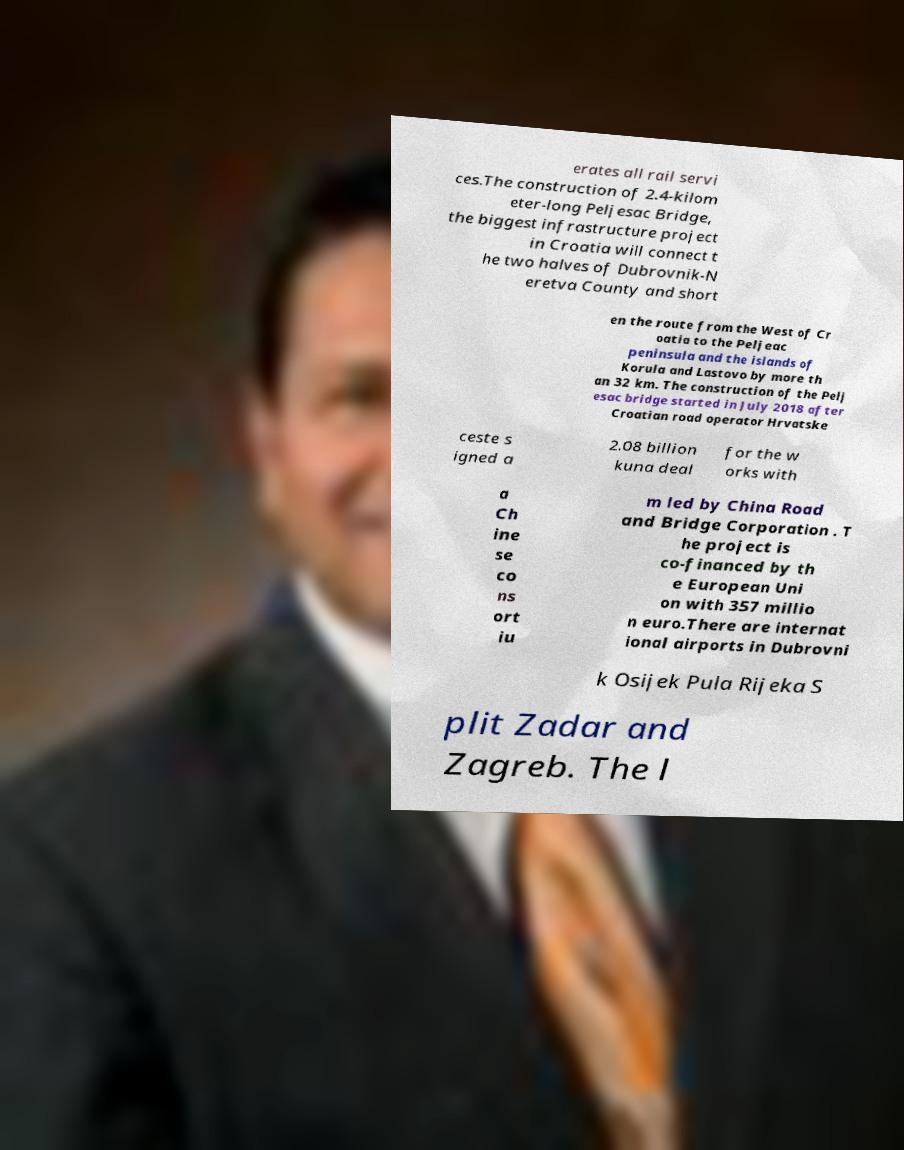What messages or text are displayed in this image? I need them in a readable, typed format. erates all rail servi ces.The construction of 2.4-kilom eter-long Peljesac Bridge, the biggest infrastructure project in Croatia will connect t he two halves of Dubrovnik-N eretva County and short en the route from the West of Cr oatia to the Peljeac peninsula and the islands of Korula and Lastovo by more th an 32 km. The construction of the Pelj esac bridge started in July 2018 after Croatian road operator Hrvatske ceste s igned a 2.08 billion kuna deal for the w orks with a Ch ine se co ns ort iu m led by China Road and Bridge Corporation . T he project is co-financed by th e European Uni on with 357 millio n euro.There are internat ional airports in Dubrovni k Osijek Pula Rijeka S plit Zadar and Zagreb. The l 